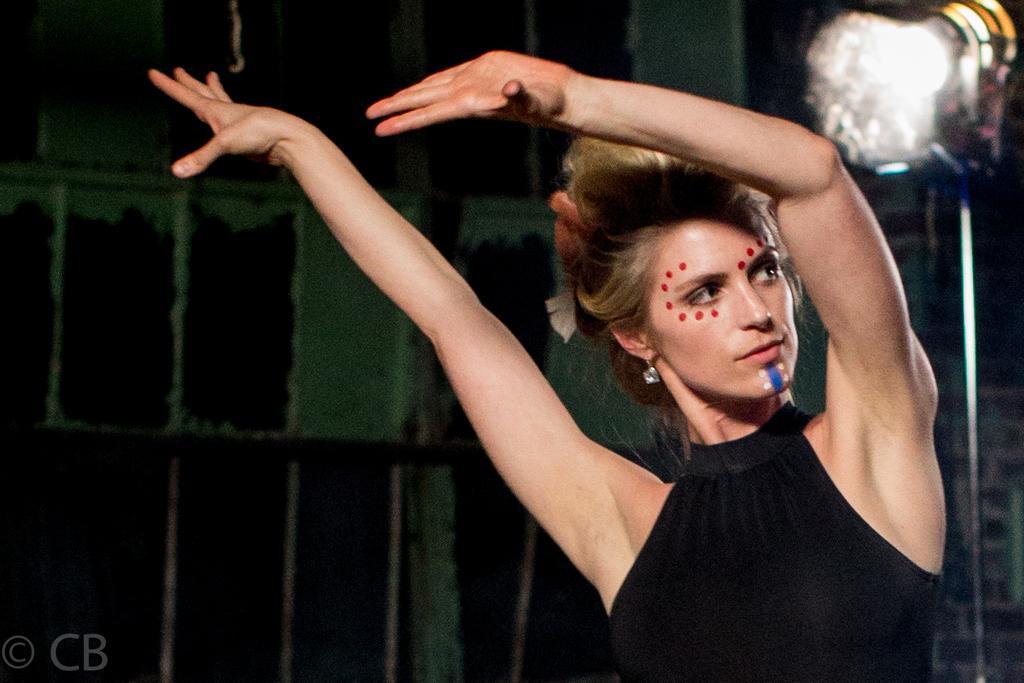Describe this image in one or two sentences. This image consists of a woman wearing black dress and dancing. To the right, there is a stand to which a light is fixed. In the background, there is a wall. 